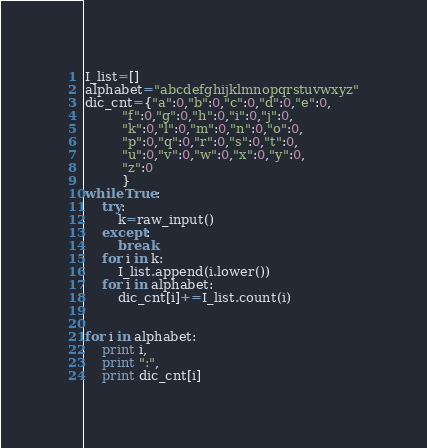Convert code to text. <code><loc_0><loc_0><loc_500><loc_500><_Python_>I_list=[]
alphabet="abcdefghijklmnopqrstuvwxyz"
dic_cnt={"a":0,"b":0,"c":0,"d":0,"e":0,
         "f":0,"g":0,"h":0,"i":0,"j":0,
         "k":0,"l":0,"m":0,"n":0,"o":0,
         "p":0,"q":0,"r":0,"s":0,"t":0,
         "u":0,"v":0,"w":0,"x":0,"y":0,
         "z":0
         }
while True:
	try:
		k=raw_input()
	except:
		break
	for i in k:
		I_list.append(i.lower())
	for i in alphabet:
		dic_cnt[i]+=I_list.count(i)
	
	
for i in alphabet:
	print i,
	print ":",
	print dic_cnt[i]</code> 